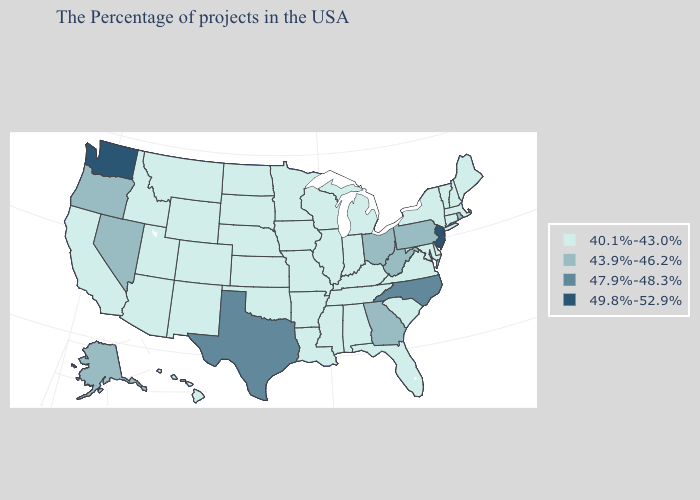Does New Jersey have the highest value in the Northeast?
Answer briefly. Yes. Does Oregon have the lowest value in the West?
Quick response, please. No. Name the states that have a value in the range 49.8%-52.9%?
Answer briefly. New Jersey, Washington. Does Arizona have a higher value than Arkansas?
Write a very short answer. No. Name the states that have a value in the range 40.1%-43.0%?
Answer briefly. Maine, Massachusetts, New Hampshire, Vermont, Connecticut, New York, Delaware, Maryland, Virginia, South Carolina, Florida, Michigan, Kentucky, Indiana, Alabama, Tennessee, Wisconsin, Illinois, Mississippi, Louisiana, Missouri, Arkansas, Minnesota, Iowa, Kansas, Nebraska, Oklahoma, South Dakota, North Dakota, Wyoming, Colorado, New Mexico, Utah, Montana, Arizona, Idaho, California, Hawaii. What is the value of Washington?
Concise answer only. 49.8%-52.9%. Which states hav the highest value in the MidWest?
Give a very brief answer. Ohio. What is the lowest value in the MidWest?
Keep it brief. 40.1%-43.0%. Does Washington have the highest value in the USA?
Give a very brief answer. Yes. Among the states that border West Virginia , which have the highest value?
Answer briefly. Pennsylvania, Ohio. Name the states that have a value in the range 49.8%-52.9%?
Answer briefly. New Jersey, Washington. What is the highest value in the MidWest ?
Give a very brief answer. 43.9%-46.2%. Name the states that have a value in the range 47.9%-48.3%?
Keep it brief. North Carolina, Texas. Among the states that border North Carolina , does Tennessee have the lowest value?
Keep it brief. Yes. Does New Jersey have the highest value in the USA?
Write a very short answer. Yes. 